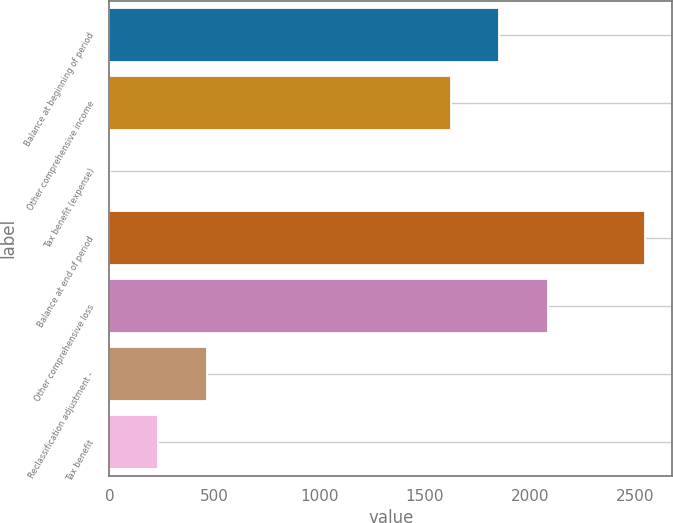<chart> <loc_0><loc_0><loc_500><loc_500><bar_chart><fcel>Balance at beginning of period<fcel>Other comprehensive income<fcel>Tax benefit (expense)<fcel>Balance at end of period<fcel>Other comprehensive loss<fcel>Reclassification adjustment -<fcel>Tax benefit<nl><fcel>1853.8<fcel>1622.2<fcel>1<fcel>2548.6<fcel>2085.4<fcel>464.2<fcel>232.6<nl></chart> 